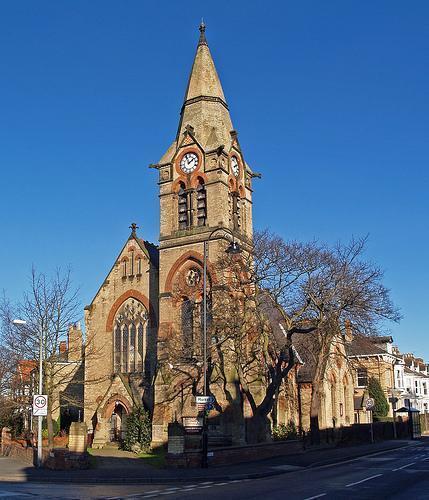How many churches are pictured?
Give a very brief answer. 1. 